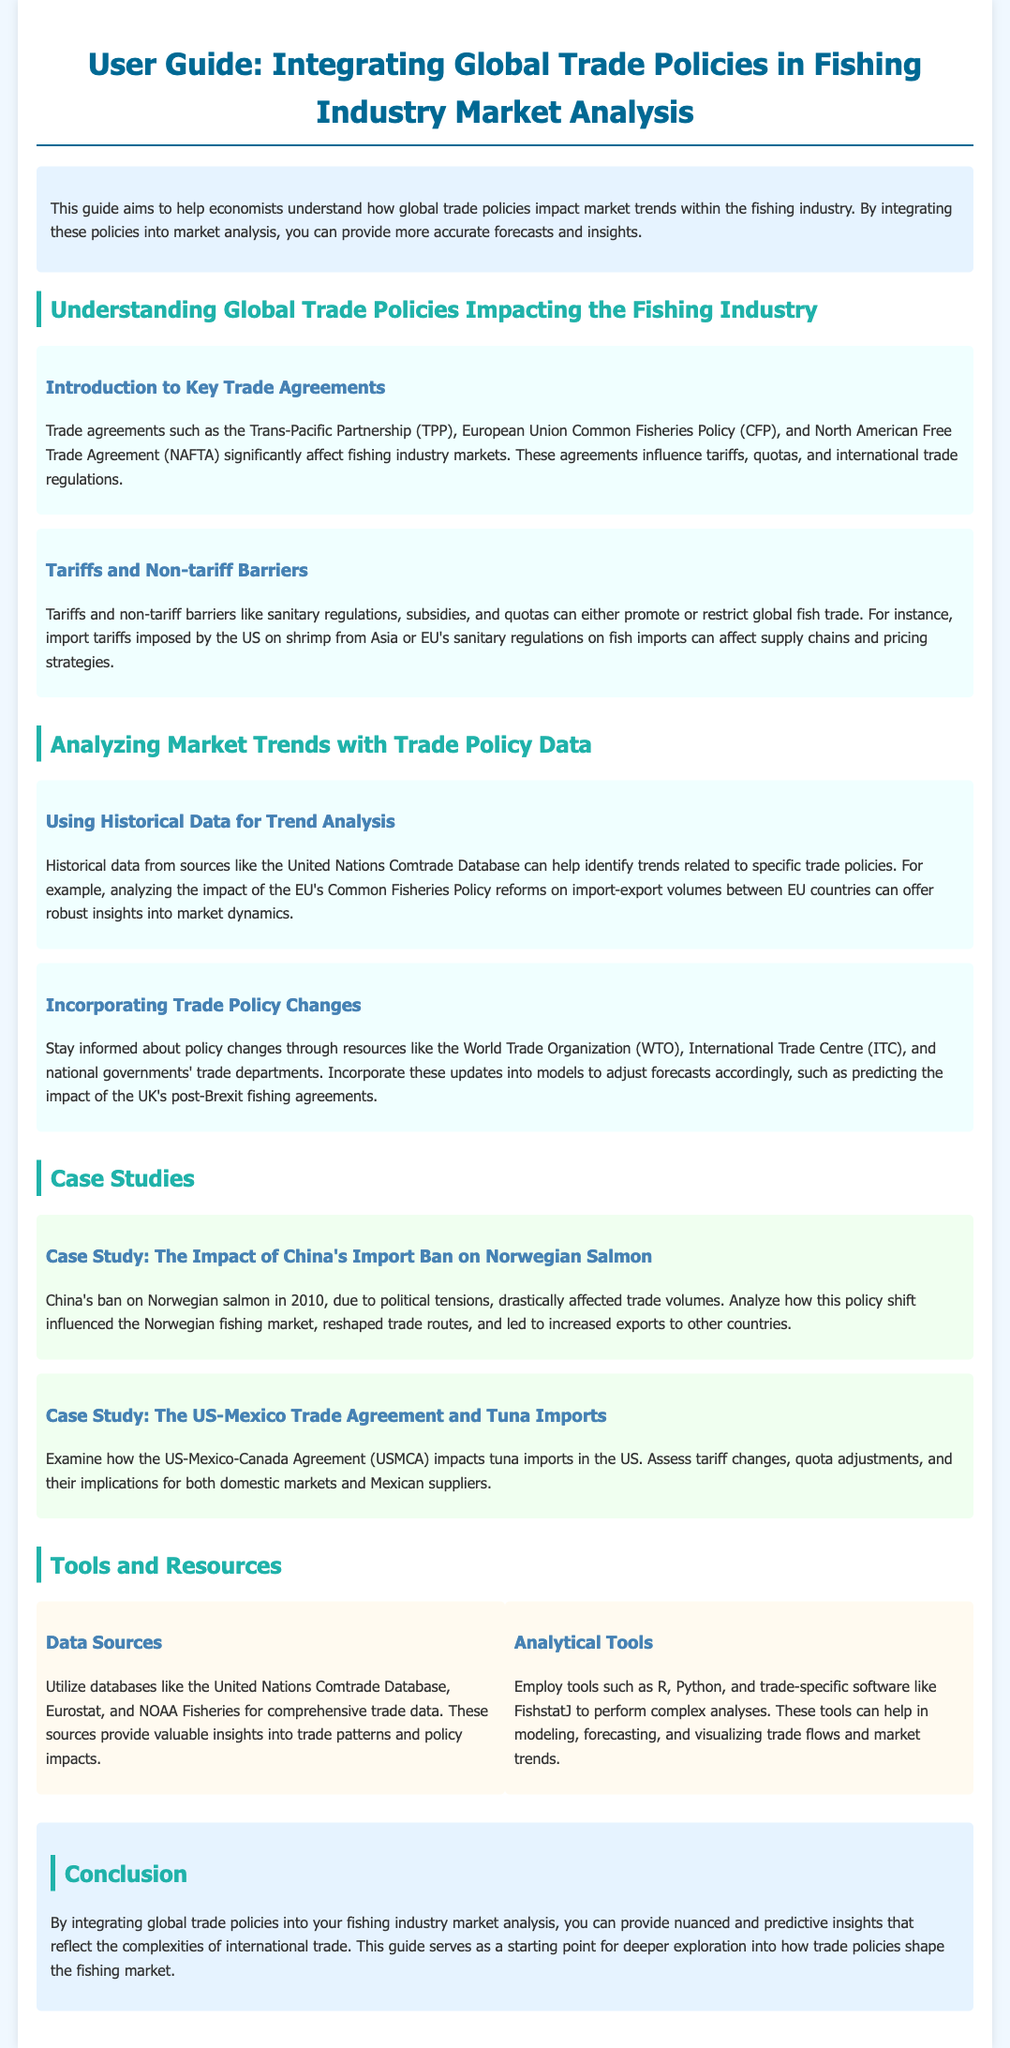What is the title of the user guide? The title of the user guide is prominently displayed at the top of the document, which indicates the subject focus.
Answer: Integrating Global Trade Policies in Fishing Industry Market Analysis What does the introduction section highlight? The introduction section emphasizes the purpose of the guide regarding global trade policies' impact on market trends.
Answer: Understanding how global trade policies impact market trends What is one example of a trade agreement mentioned? The document provides specific examples of trade agreements that affect the fishing industry.
Answer: Trans-Pacific Partnership (TPP) What significant impact does tariffs have according to the document? The subsection on tariffs and non-tariff barriers outlines how these can influence global fish trade.
Answer: Promote or restrict global fish trade What is a tool recommended for complex analyses? The tools section suggests certain analytical tools useful for data analysis in the fishing industry context.
Answer: R What case study discusses Norway's salmon issue? The document mentions specific case studies that exemplify trade policy impacts in real-world scenarios.
Answer: The Impact of China's Import Ban on Norwegian Salmon How can one stay informed about trade policy changes? A specific section advises readers on how to remain updated on changes that may affect market forecasts.
Answer: Utilize resources like WTO, ITC, and national governments' trade departments What two databases are recommended for data sources? The tools and resources section specifies various databases that can provide trade data for analysis.
Answer: United Nations Comtrade Database, Eurostat What is the concluding aim of integrating trade policies into analysis? The conclusion summarizes the ultimate goal of the guide regarding market analysis and trade policies.
Answer: Provide nuanced and predictive insights 